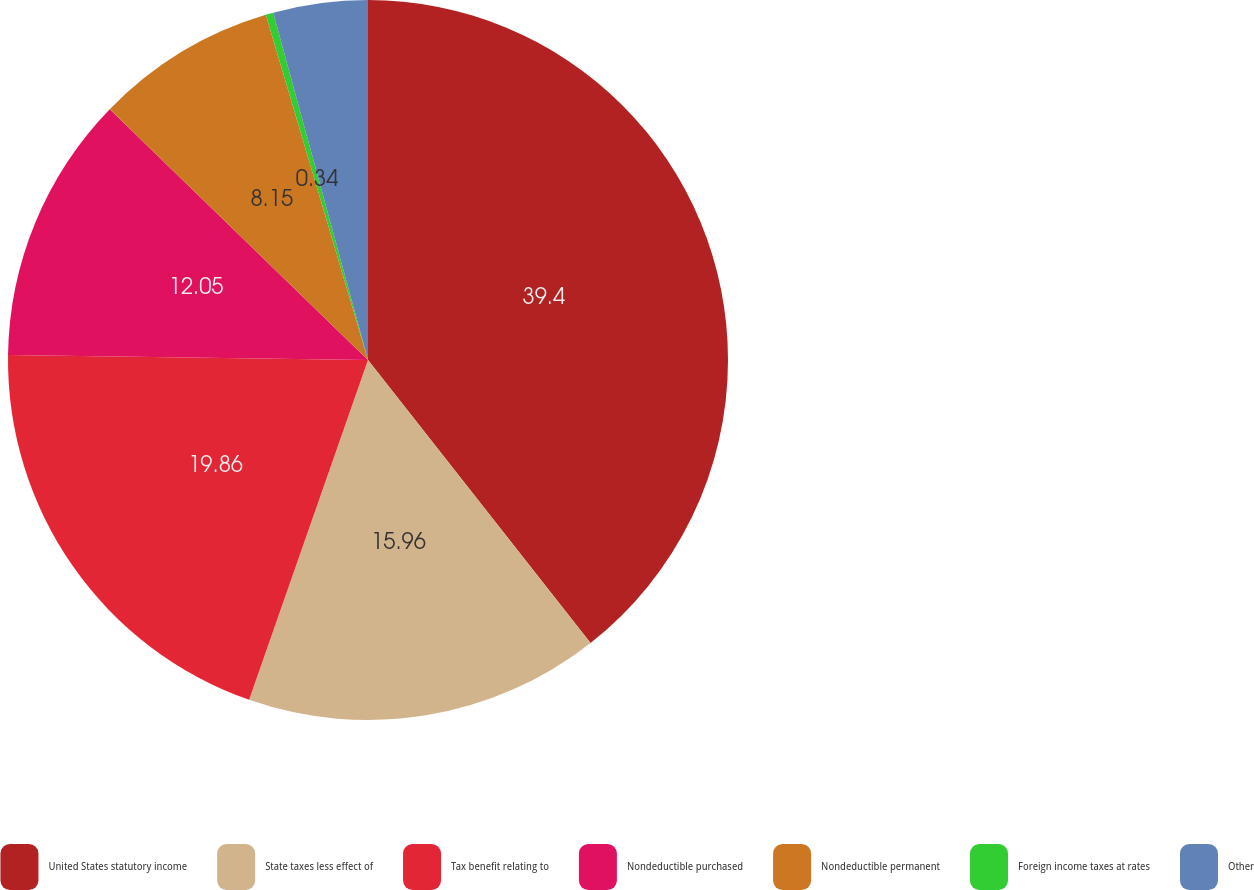Convert chart to OTSL. <chart><loc_0><loc_0><loc_500><loc_500><pie_chart><fcel>United States statutory income<fcel>State taxes less effect of<fcel>Tax benefit relating to<fcel>Nondeductible purchased<fcel>Nondeductible permanent<fcel>Foreign income taxes at rates<fcel>Other<nl><fcel>39.39%<fcel>15.96%<fcel>19.86%<fcel>12.05%<fcel>8.15%<fcel>0.34%<fcel>4.24%<nl></chart> 